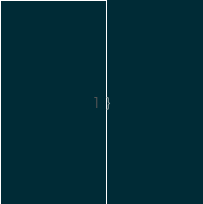<code> <loc_0><loc_0><loc_500><loc_500><_Scala_>}
</code> 